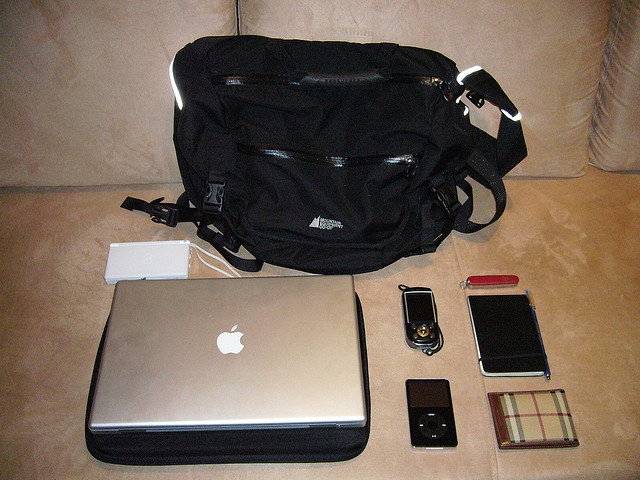Describe the objects in this image and their specific colors. I can see couch in black, gray, tan, and darkgray tones, laptop in black, darkgray, gray, and lightgray tones, cell phone in black, tan, navy, and gray tones, cell phone in black, darkgray, and tan tones, and cell phone in black, gray, darkgray, and olive tones in this image. 